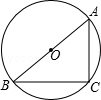Explore how the diagram might change if point C were moved along the circumference to position C'. How would this affect the other angles within the triangle? If point C were moved along the circumference to a new position C', the angles within triangle ABC would adjust. Angle ACB would remain a right angle given that AB is the diameter. However, both angles BAC and BCA would change depending on the arc between points A and C'. The angle BAC would become smaller or larger based on whether C' moves closer to or farther from A. 